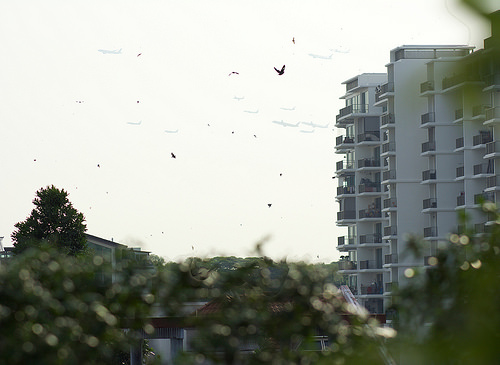<image>
Can you confirm if the bird is in front of the building? Yes. The bird is positioned in front of the building, appearing closer to the camera viewpoint. 